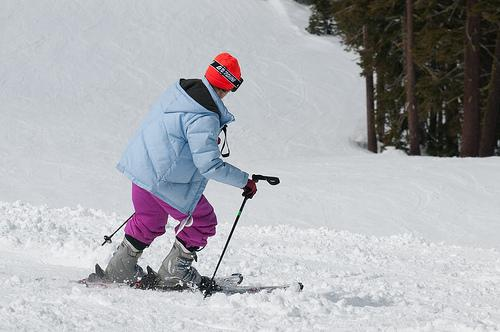Narrate the image by focusing on the main subject and their clothing. In the image, a woman clad in a red hat, goggles, blue jacket, purple pants, and grey boots skis down a snowy hill. Briefly describe the main character's appearance and actions in the image. A woman dressed in colorful winter attire is skiing down a slope covered in snow. Briefly mention the main activity happening in the image and the attire of the main subject. A person is skiing down a hill, wearing an orange hat, blue jacket, purple pants, and ski boots. Provide a simple description of the person and their activity in the image. A woman in colorful winter clothes is skiing down a snowy hill. Explain the primary focus of the image by mentioning the person and their outfit. A woman wearing a winter outfit with a red hat, blue jacket, purple pants, and grey boots is skiing on snow-covered ground. Mention the skiing person's outfit and the surrounding environment in a concise way. A woman in a red hat, blue jacket, purple pants, and grey boots skis down a hill covered in snow and trees. Describe the main subject in the image and the prominent colors of their attire. The image features a woman skiing with an outfit featuring a red hat, blue jacket, purple pants, and grey boots. Provide a detailed description of the most prominent person in the image. A woman wearing a red hat, goggles, blue jacket with a hood, purple ski pants, and grey ski boots is skiing down a hill holding a ski pole. In a straightforward manner, state the primary action and subject in the image. There is a woman skiing in the snow, wearing colorful winter attire. Describe the scene of the image, focusing on the person and their clothing. The image portrays a snowy scene with a woman dressed in a red hat, goggles, a blue hooded jacket, purple ski pants, and grey ski boots, as she skis down a hill. 